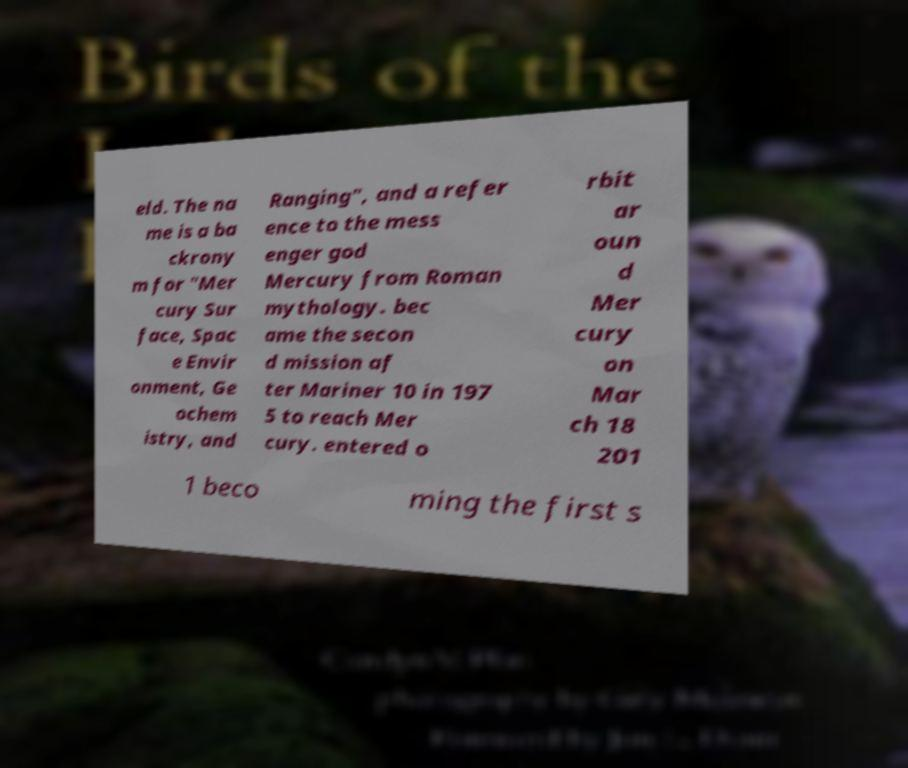What messages or text are displayed in this image? I need them in a readable, typed format. eld. The na me is a ba ckrony m for "Mer cury Sur face, Spac e Envir onment, Ge ochem istry, and Ranging", and a refer ence to the mess enger god Mercury from Roman mythology. bec ame the secon d mission af ter Mariner 10 in 197 5 to reach Mer cury. entered o rbit ar oun d Mer cury on Mar ch 18 201 1 beco ming the first s 